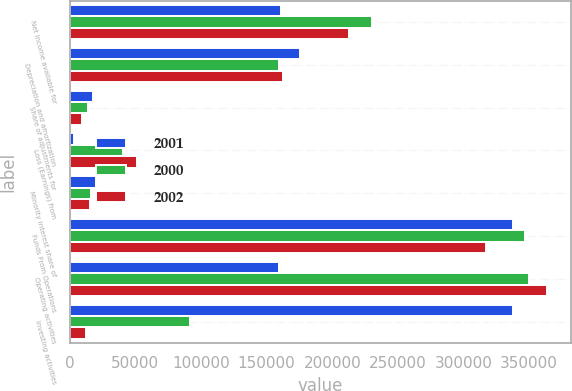<chart> <loc_0><loc_0><loc_500><loc_500><stacked_bar_chart><ecel><fcel>Net income available for<fcel>Depreciation and amortization<fcel>Share of adjustments for<fcel>Loss (Earnings) from<fcel>Minority interest share of<fcel>Funds From Operations<fcel>Operating activities<fcel>Investing activities<nl><fcel>2001<fcel>161272<fcel>175621<fcel>17657<fcel>3430<fcel>20329<fcel>337651<fcel>159714<fcel>337972<nl><fcel>2000<fcel>229967<fcel>159714<fcel>14177<fcel>40628<fcel>16483<fcel>346747<fcel>349668<fcel>91539<nl><fcel>2002<fcel>212958<fcel>162523<fcel>9104<fcel>51527<fcel>15698<fcel>317360<fcel>363350<fcel>11972<nl></chart> 